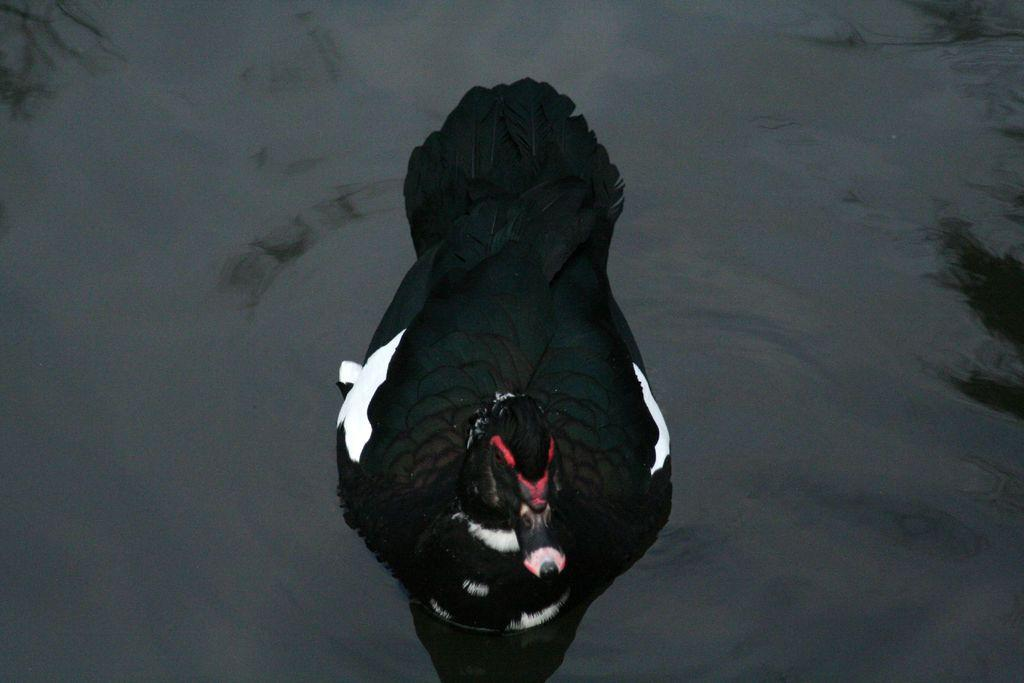Where was the image taken? The image was clicked outside. What type of bird can be seen in the image? There is a black color bird in the image. Can you describe the bird's surroundings? The bird appears to be in a water body. What book is the bird holding in its beak in the image? There is no book present in the image; the bird is in a water body. 